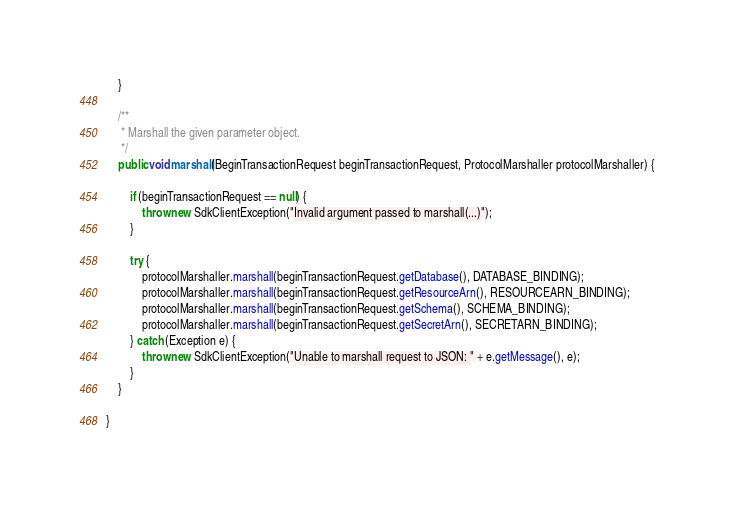<code> <loc_0><loc_0><loc_500><loc_500><_Java_>    }

    /**
     * Marshall the given parameter object.
     */
    public void marshall(BeginTransactionRequest beginTransactionRequest, ProtocolMarshaller protocolMarshaller) {

        if (beginTransactionRequest == null) {
            throw new SdkClientException("Invalid argument passed to marshall(...)");
        }

        try {
            protocolMarshaller.marshall(beginTransactionRequest.getDatabase(), DATABASE_BINDING);
            protocolMarshaller.marshall(beginTransactionRequest.getResourceArn(), RESOURCEARN_BINDING);
            protocolMarshaller.marshall(beginTransactionRequest.getSchema(), SCHEMA_BINDING);
            protocolMarshaller.marshall(beginTransactionRequest.getSecretArn(), SECRETARN_BINDING);
        } catch (Exception e) {
            throw new SdkClientException("Unable to marshall request to JSON: " + e.getMessage(), e);
        }
    }

}
</code> 